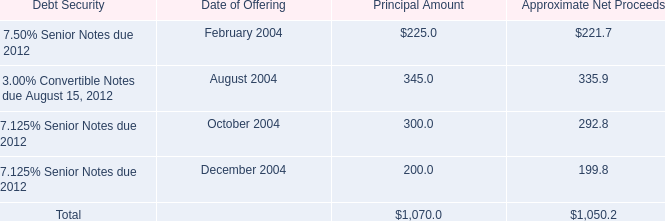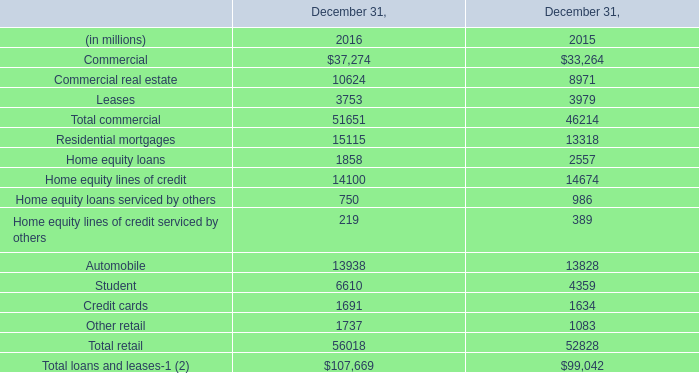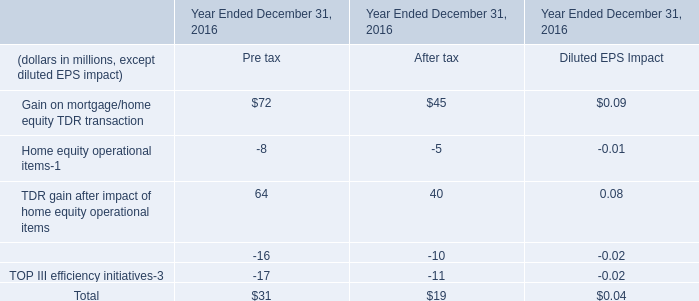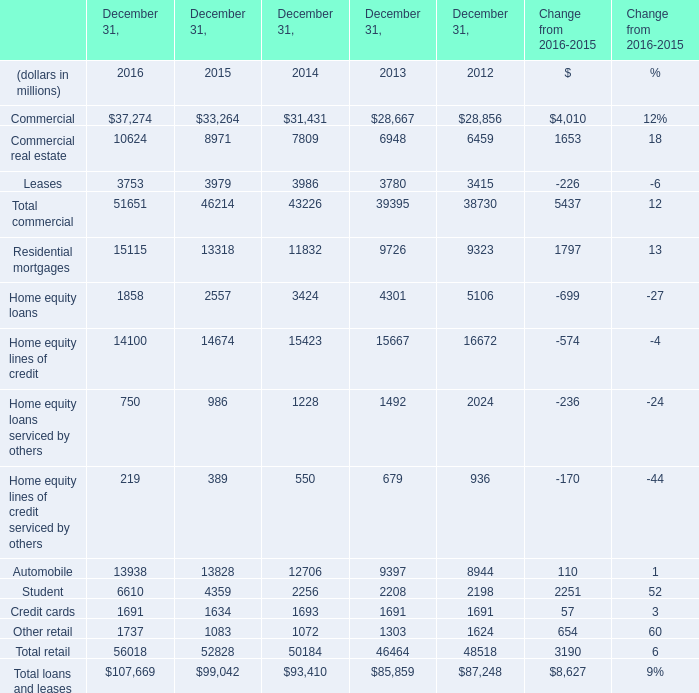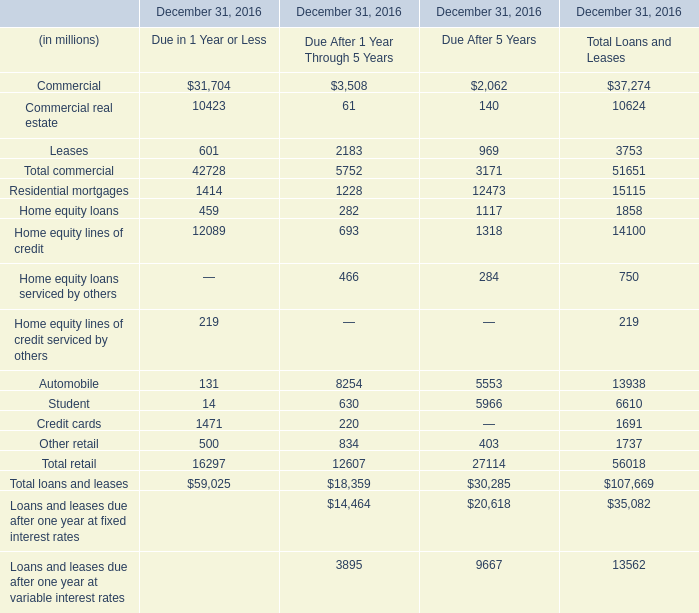What's the average of Student of December 31, 2013, and Commercial of December 31, 2016 ? 
Computations: ((2208.0 + 37274.0) / 2)
Answer: 19741.0. 